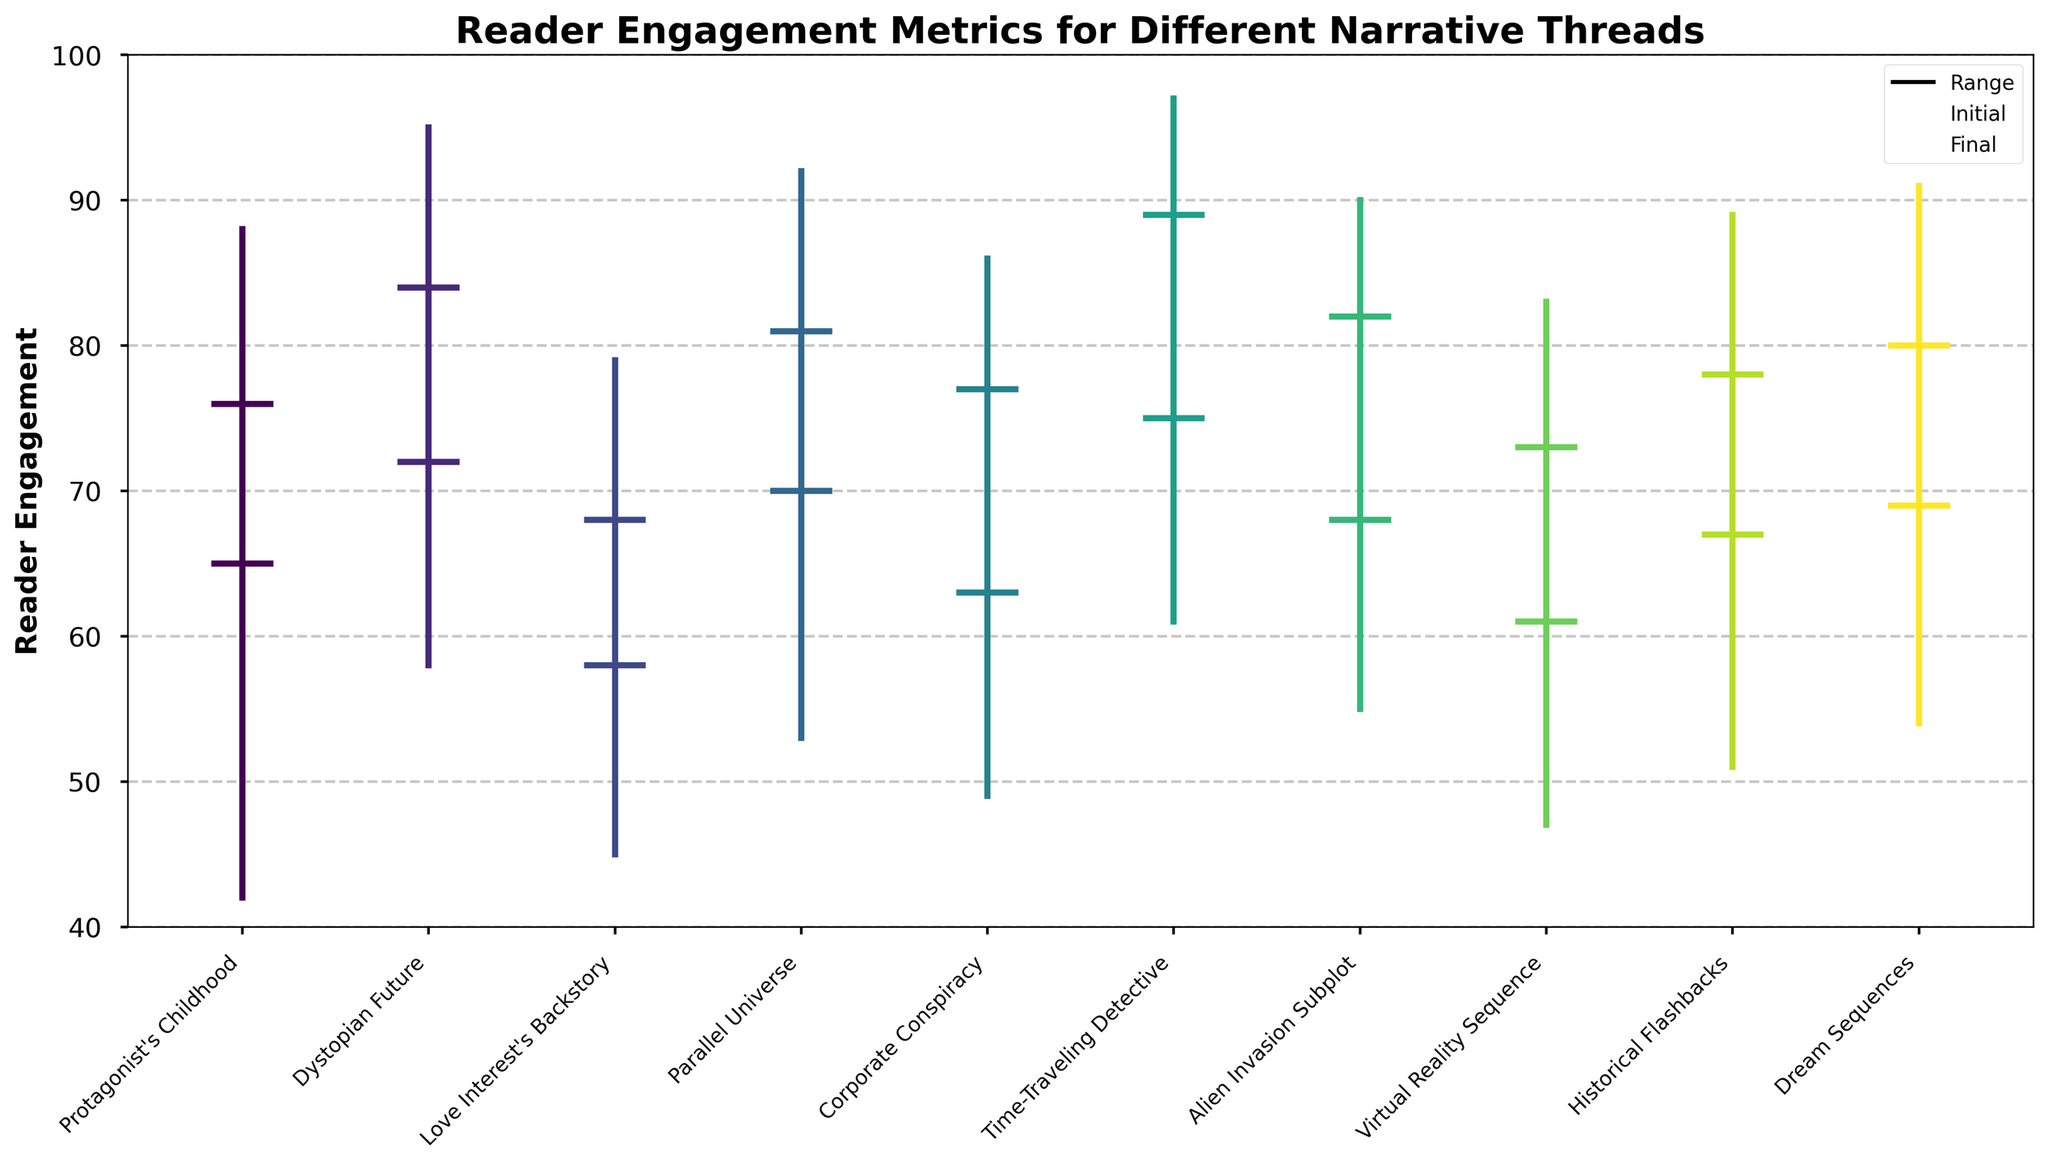What's the title of the plot? The title of the plot is displayed at the top of the chart.
Answer: Reader Engagement Metrics for Different Narrative Threads Which narrative thread had the highest initial reader engagement? By examining the initial values for each narrative thread, the thread with the highest initial reader engagement can be identified.
Answer: Time-Traveling Detective What's the average final engagement across all narrative threads? To find the average final engagement, sum the final engagement values of all ten narrative threads and divide by the number of threads. The final engagement values are 76, 84, 68, 81, 77, 89, 82, 73, 78, and 80, making the total 788. Since there are ten threads, the average final engagement is 788 / 10.
Answer: 78.8 Which narrative thread shows the greatest range in reader engagement? The range is calculated by subtracting the lowest engagement from the highest engagement for each thread. Identify the thread with the largest difference.
Answer: Time-Traveling Detective What is the reader engagement drop from the highest point to the lowest point for the Corporate Conspiracy thread? Subtract the lowest engagement value from the highest engagement value for the Corporate Conspiracy thread. The engagement drops from 86 to 49.
Answer: 37 Which narrative thread ends with a higher engagement than it started? Compare the initial and final engagement values for each thread to see which ones have a higher final engagement than the initial engagement.
Answer: All except Love Interest's Backstory How many narrative threads have a final engagement above 80? Count the number of narrative threads with a final engagement value greater than 80.
Answer: 5 Which narrative thread has the closest initial and final engagement values? The difference between initial and final engagement values is calculated for each thread. The thread with the smallest difference is the one with the closest values.
Answer: Virtual Reality Sequence Between the Alien Invasion Subplot and the Dream Sequences thread, which one has the higher final engagement? Compare the final engagement values of the Alien Invasion Subplot (82) and the Dream Sequences (80).
Answer: Alien Invasion Subplot What is the total sum of the lowest engagement values across all narrative threads? Add up the lowest engagement values of all ten narrative threads. The values are 42, 58, 45, 53, 49, 61, 55, 47, 51, and 54, making the total 515.
Answer: 515 